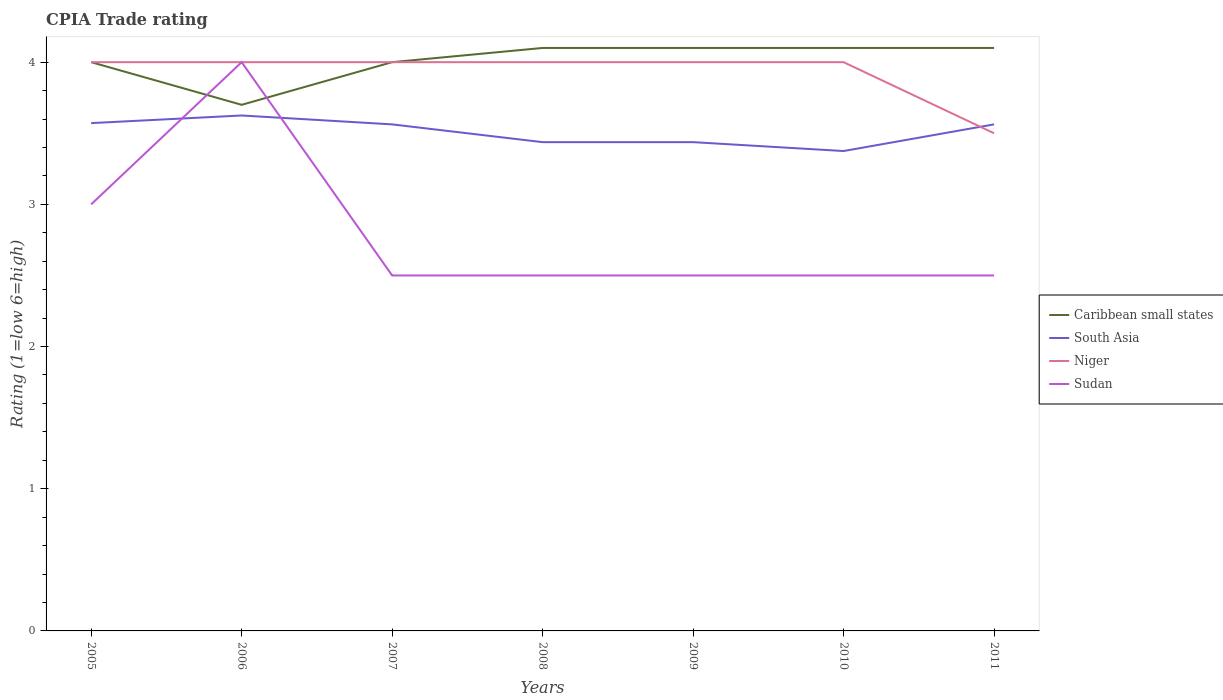Does the line corresponding to Niger intersect with the line corresponding to Sudan?
Your response must be concise. Yes. Is the number of lines equal to the number of legend labels?
Offer a terse response. Yes. Across all years, what is the maximum CPIA rating in Caribbean small states?
Offer a very short reply. 3.7. What is the total CPIA rating in Niger in the graph?
Keep it short and to the point. 0. What is the difference between the highest and the second highest CPIA rating in Caribbean small states?
Provide a short and direct response. 0.4. What is the difference between the highest and the lowest CPIA rating in South Asia?
Your answer should be very brief. 4. Is the CPIA rating in South Asia strictly greater than the CPIA rating in Niger over the years?
Make the answer very short. No. How many years are there in the graph?
Your answer should be very brief. 7. What is the difference between two consecutive major ticks on the Y-axis?
Keep it short and to the point. 1. Are the values on the major ticks of Y-axis written in scientific E-notation?
Keep it short and to the point. No. How many legend labels are there?
Your answer should be compact. 4. How are the legend labels stacked?
Offer a terse response. Vertical. What is the title of the graph?
Ensure brevity in your answer.  CPIA Trade rating. Does "Cote d'Ivoire" appear as one of the legend labels in the graph?
Your response must be concise. No. What is the label or title of the X-axis?
Keep it short and to the point. Years. What is the label or title of the Y-axis?
Your answer should be very brief. Rating (1=low 6=high). What is the Rating (1=low 6=high) of South Asia in 2005?
Provide a succinct answer. 3.57. What is the Rating (1=low 6=high) in South Asia in 2006?
Your answer should be very brief. 3.62. What is the Rating (1=low 6=high) in Caribbean small states in 2007?
Make the answer very short. 4. What is the Rating (1=low 6=high) in South Asia in 2007?
Keep it short and to the point. 3.56. What is the Rating (1=low 6=high) of Niger in 2007?
Offer a terse response. 4. What is the Rating (1=low 6=high) in Sudan in 2007?
Keep it short and to the point. 2.5. What is the Rating (1=low 6=high) in South Asia in 2008?
Your answer should be very brief. 3.44. What is the Rating (1=low 6=high) in Caribbean small states in 2009?
Your answer should be very brief. 4.1. What is the Rating (1=low 6=high) of South Asia in 2009?
Provide a succinct answer. 3.44. What is the Rating (1=low 6=high) in Niger in 2009?
Your answer should be compact. 4. What is the Rating (1=low 6=high) of Sudan in 2009?
Make the answer very short. 2.5. What is the Rating (1=low 6=high) in Caribbean small states in 2010?
Make the answer very short. 4.1. What is the Rating (1=low 6=high) in South Asia in 2010?
Offer a very short reply. 3.38. What is the Rating (1=low 6=high) of Niger in 2010?
Provide a short and direct response. 4. What is the Rating (1=low 6=high) in Sudan in 2010?
Your answer should be very brief. 2.5. What is the Rating (1=low 6=high) in South Asia in 2011?
Your answer should be very brief. 3.56. What is the Rating (1=low 6=high) of Niger in 2011?
Your response must be concise. 3.5. Across all years, what is the maximum Rating (1=low 6=high) in South Asia?
Provide a short and direct response. 3.62. Across all years, what is the maximum Rating (1=low 6=high) of Sudan?
Make the answer very short. 4. Across all years, what is the minimum Rating (1=low 6=high) in South Asia?
Ensure brevity in your answer.  3.38. Across all years, what is the minimum Rating (1=low 6=high) in Niger?
Ensure brevity in your answer.  3.5. What is the total Rating (1=low 6=high) of Caribbean small states in the graph?
Provide a succinct answer. 28.1. What is the total Rating (1=low 6=high) of South Asia in the graph?
Offer a very short reply. 24.57. What is the total Rating (1=low 6=high) of Niger in the graph?
Your response must be concise. 27.5. What is the total Rating (1=low 6=high) of Sudan in the graph?
Offer a terse response. 19.5. What is the difference between the Rating (1=low 6=high) in South Asia in 2005 and that in 2006?
Offer a terse response. -0.05. What is the difference between the Rating (1=low 6=high) of Sudan in 2005 and that in 2006?
Keep it short and to the point. -1. What is the difference between the Rating (1=low 6=high) in Caribbean small states in 2005 and that in 2007?
Offer a terse response. 0. What is the difference between the Rating (1=low 6=high) of South Asia in 2005 and that in 2007?
Your answer should be very brief. 0.01. What is the difference between the Rating (1=low 6=high) of Niger in 2005 and that in 2007?
Ensure brevity in your answer.  0. What is the difference between the Rating (1=low 6=high) of Caribbean small states in 2005 and that in 2008?
Your answer should be very brief. -0.1. What is the difference between the Rating (1=low 6=high) of South Asia in 2005 and that in 2008?
Give a very brief answer. 0.13. What is the difference between the Rating (1=low 6=high) in Sudan in 2005 and that in 2008?
Ensure brevity in your answer.  0.5. What is the difference between the Rating (1=low 6=high) of Caribbean small states in 2005 and that in 2009?
Provide a short and direct response. -0.1. What is the difference between the Rating (1=low 6=high) of South Asia in 2005 and that in 2009?
Ensure brevity in your answer.  0.13. What is the difference between the Rating (1=low 6=high) of Sudan in 2005 and that in 2009?
Offer a terse response. 0.5. What is the difference between the Rating (1=low 6=high) of Caribbean small states in 2005 and that in 2010?
Your response must be concise. -0.1. What is the difference between the Rating (1=low 6=high) in South Asia in 2005 and that in 2010?
Your answer should be very brief. 0.2. What is the difference between the Rating (1=low 6=high) in Niger in 2005 and that in 2010?
Offer a terse response. 0. What is the difference between the Rating (1=low 6=high) in South Asia in 2005 and that in 2011?
Your response must be concise. 0.01. What is the difference between the Rating (1=low 6=high) in Niger in 2005 and that in 2011?
Your answer should be compact. 0.5. What is the difference between the Rating (1=low 6=high) of Caribbean small states in 2006 and that in 2007?
Offer a very short reply. -0.3. What is the difference between the Rating (1=low 6=high) in South Asia in 2006 and that in 2007?
Your response must be concise. 0.06. What is the difference between the Rating (1=low 6=high) in Sudan in 2006 and that in 2007?
Provide a succinct answer. 1.5. What is the difference between the Rating (1=low 6=high) of South Asia in 2006 and that in 2008?
Your answer should be compact. 0.19. What is the difference between the Rating (1=low 6=high) in South Asia in 2006 and that in 2009?
Your response must be concise. 0.19. What is the difference between the Rating (1=low 6=high) of Niger in 2006 and that in 2009?
Provide a short and direct response. 0. What is the difference between the Rating (1=low 6=high) of Caribbean small states in 2006 and that in 2010?
Your answer should be very brief. -0.4. What is the difference between the Rating (1=low 6=high) in South Asia in 2006 and that in 2010?
Provide a short and direct response. 0.25. What is the difference between the Rating (1=low 6=high) of Sudan in 2006 and that in 2010?
Provide a short and direct response. 1.5. What is the difference between the Rating (1=low 6=high) in Caribbean small states in 2006 and that in 2011?
Your answer should be compact. -0.4. What is the difference between the Rating (1=low 6=high) in South Asia in 2006 and that in 2011?
Provide a short and direct response. 0.06. What is the difference between the Rating (1=low 6=high) of Niger in 2006 and that in 2011?
Keep it short and to the point. 0.5. What is the difference between the Rating (1=low 6=high) in Sudan in 2006 and that in 2011?
Offer a terse response. 1.5. What is the difference between the Rating (1=low 6=high) in Caribbean small states in 2007 and that in 2009?
Your response must be concise. -0.1. What is the difference between the Rating (1=low 6=high) of Niger in 2007 and that in 2009?
Offer a very short reply. 0. What is the difference between the Rating (1=low 6=high) of Caribbean small states in 2007 and that in 2010?
Offer a terse response. -0.1. What is the difference between the Rating (1=low 6=high) in South Asia in 2007 and that in 2010?
Your answer should be compact. 0.19. What is the difference between the Rating (1=low 6=high) in Sudan in 2007 and that in 2010?
Offer a very short reply. 0. What is the difference between the Rating (1=low 6=high) of Caribbean small states in 2007 and that in 2011?
Offer a very short reply. -0.1. What is the difference between the Rating (1=low 6=high) of South Asia in 2007 and that in 2011?
Ensure brevity in your answer.  0. What is the difference between the Rating (1=low 6=high) of Niger in 2007 and that in 2011?
Ensure brevity in your answer.  0.5. What is the difference between the Rating (1=low 6=high) of Sudan in 2007 and that in 2011?
Make the answer very short. 0. What is the difference between the Rating (1=low 6=high) in Niger in 2008 and that in 2009?
Make the answer very short. 0. What is the difference between the Rating (1=low 6=high) in South Asia in 2008 and that in 2010?
Give a very brief answer. 0.06. What is the difference between the Rating (1=low 6=high) in South Asia in 2008 and that in 2011?
Make the answer very short. -0.12. What is the difference between the Rating (1=low 6=high) of Caribbean small states in 2009 and that in 2010?
Offer a terse response. 0. What is the difference between the Rating (1=low 6=high) in South Asia in 2009 and that in 2010?
Provide a succinct answer. 0.06. What is the difference between the Rating (1=low 6=high) in Niger in 2009 and that in 2010?
Keep it short and to the point. 0. What is the difference between the Rating (1=low 6=high) in South Asia in 2009 and that in 2011?
Keep it short and to the point. -0.12. What is the difference between the Rating (1=low 6=high) of Sudan in 2009 and that in 2011?
Provide a succinct answer. 0. What is the difference between the Rating (1=low 6=high) in South Asia in 2010 and that in 2011?
Offer a terse response. -0.19. What is the difference between the Rating (1=low 6=high) of Niger in 2010 and that in 2011?
Your response must be concise. 0.5. What is the difference between the Rating (1=low 6=high) of Sudan in 2010 and that in 2011?
Provide a short and direct response. 0. What is the difference between the Rating (1=low 6=high) in Caribbean small states in 2005 and the Rating (1=low 6=high) in South Asia in 2006?
Your answer should be very brief. 0.38. What is the difference between the Rating (1=low 6=high) in Caribbean small states in 2005 and the Rating (1=low 6=high) in Niger in 2006?
Provide a short and direct response. 0. What is the difference between the Rating (1=low 6=high) in Caribbean small states in 2005 and the Rating (1=low 6=high) in Sudan in 2006?
Provide a succinct answer. 0. What is the difference between the Rating (1=low 6=high) in South Asia in 2005 and the Rating (1=low 6=high) in Niger in 2006?
Your response must be concise. -0.43. What is the difference between the Rating (1=low 6=high) in South Asia in 2005 and the Rating (1=low 6=high) in Sudan in 2006?
Your answer should be very brief. -0.43. What is the difference between the Rating (1=low 6=high) of Caribbean small states in 2005 and the Rating (1=low 6=high) of South Asia in 2007?
Ensure brevity in your answer.  0.44. What is the difference between the Rating (1=low 6=high) in Caribbean small states in 2005 and the Rating (1=low 6=high) in Niger in 2007?
Keep it short and to the point. 0. What is the difference between the Rating (1=low 6=high) in South Asia in 2005 and the Rating (1=low 6=high) in Niger in 2007?
Ensure brevity in your answer.  -0.43. What is the difference between the Rating (1=low 6=high) of South Asia in 2005 and the Rating (1=low 6=high) of Sudan in 2007?
Offer a very short reply. 1.07. What is the difference between the Rating (1=low 6=high) in Caribbean small states in 2005 and the Rating (1=low 6=high) in South Asia in 2008?
Your response must be concise. 0.56. What is the difference between the Rating (1=low 6=high) of Caribbean small states in 2005 and the Rating (1=low 6=high) of Niger in 2008?
Offer a terse response. 0. What is the difference between the Rating (1=low 6=high) of South Asia in 2005 and the Rating (1=low 6=high) of Niger in 2008?
Your answer should be very brief. -0.43. What is the difference between the Rating (1=low 6=high) of South Asia in 2005 and the Rating (1=low 6=high) of Sudan in 2008?
Your answer should be compact. 1.07. What is the difference between the Rating (1=low 6=high) in Niger in 2005 and the Rating (1=low 6=high) in Sudan in 2008?
Your response must be concise. 1.5. What is the difference between the Rating (1=low 6=high) in Caribbean small states in 2005 and the Rating (1=low 6=high) in South Asia in 2009?
Ensure brevity in your answer.  0.56. What is the difference between the Rating (1=low 6=high) in Caribbean small states in 2005 and the Rating (1=low 6=high) in Sudan in 2009?
Offer a very short reply. 1.5. What is the difference between the Rating (1=low 6=high) in South Asia in 2005 and the Rating (1=low 6=high) in Niger in 2009?
Your answer should be compact. -0.43. What is the difference between the Rating (1=low 6=high) in South Asia in 2005 and the Rating (1=low 6=high) in Sudan in 2009?
Keep it short and to the point. 1.07. What is the difference between the Rating (1=low 6=high) of Caribbean small states in 2005 and the Rating (1=low 6=high) of South Asia in 2010?
Offer a very short reply. 0.62. What is the difference between the Rating (1=low 6=high) in South Asia in 2005 and the Rating (1=low 6=high) in Niger in 2010?
Your response must be concise. -0.43. What is the difference between the Rating (1=low 6=high) of South Asia in 2005 and the Rating (1=low 6=high) of Sudan in 2010?
Your answer should be very brief. 1.07. What is the difference between the Rating (1=low 6=high) in Caribbean small states in 2005 and the Rating (1=low 6=high) in South Asia in 2011?
Provide a short and direct response. 0.44. What is the difference between the Rating (1=low 6=high) in Caribbean small states in 2005 and the Rating (1=low 6=high) in Niger in 2011?
Offer a very short reply. 0.5. What is the difference between the Rating (1=low 6=high) of Caribbean small states in 2005 and the Rating (1=low 6=high) of Sudan in 2011?
Offer a very short reply. 1.5. What is the difference between the Rating (1=low 6=high) in South Asia in 2005 and the Rating (1=low 6=high) in Niger in 2011?
Your answer should be compact. 0.07. What is the difference between the Rating (1=low 6=high) of South Asia in 2005 and the Rating (1=low 6=high) of Sudan in 2011?
Your response must be concise. 1.07. What is the difference between the Rating (1=low 6=high) in Niger in 2005 and the Rating (1=low 6=high) in Sudan in 2011?
Your response must be concise. 1.5. What is the difference between the Rating (1=low 6=high) of Caribbean small states in 2006 and the Rating (1=low 6=high) of South Asia in 2007?
Give a very brief answer. 0.14. What is the difference between the Rating (1=low 6=high) in Caribbean small states in 2006 and the Rating (1=low 6=high) in Sudan in 2007?
Your answer should be very brief. 1.2. What is the difference between the Rating (1=low 6=high) in South Asia in 2006 and the Rating (1=low 6=high) in Niger in 2007?
Keep it short and to the point. -0.38. What is the difference between the Rating (1=low 6=high) in South Asia in 2006 and the Rating (1=low 6=high) in Sudan in 2007?
Your answer should be very brief. 1.12. What is the difference between the Rating (1=low 6=high) in Niger in 2006 and the Rating (1=low 6=high) in Sudan in 2007?
Your answer should be compact. 1.5. What is the difference between the Rating (1=low 6=high) in Caribbean small states in 2006 and the Rating (1=low 6=high) in South Asia in 2008?
Make the answer very short. 0.26. What is the difference between the Rating (1=low 6=high) in Caribbean small states in 2006 and the Rating (1=low 6=high) in Niger in 2008?
Give a very brief answer. -0.3. What is the difference between the Rating (1=low 6=high) of Caribbean small states in 2006 and the Rating (1=low 6=high) of Sudan in 2008?
Make the answer very short. 1.2. What is the difference between the Rating (1=low 6=high) in South Asia in 2006 and the Rating (1=low 6=high) in Niger in 2008?
Your answer should be very brief. -0.38. What is the difference between the Rating (1=low 6=high) of Caribbean small states in 2006 and the Rating (1=low 6=high) of South Asia in 2009?
Provide a succinct answer. 0.26. What is the difference between the Rating (1=low 6=high) of Caribbean small states in 2006 and the Rating (1=low 6=high) of Niger in 2009?
Provide a short and direct response. -0.3. What is the difference between the Rating (1=low 6=high) in South Asia in 2006 and the Rating (1=low 6=high) in Niger in 2009?
Keep it short and to the point. -0.38. What is the difference between the Rating (1=low 6=high) in South Asia in 2006 and the Rating (1=low 6=high) in Sudan in 2009?
Your response must be concise. 1.12. What is the difference between the Rating (1=low 6=high) in Caribbean small states in 2006 and the Rating (1=low 6=high) in South Asia in 2010?
Your answer should be compact. 0.33. What is the difference between the Rating (1=low 6=high) in Caribbean small states in 2006 and the Rating (1=low 6=high) in Niger in 2010?
Give a very brief answer. -0.3. What is the difference between the Rating (1=low 6=high) of South Asia in 2006 and the Rating (1=low 6=high) of Niger in 2010?
Offer a terse response. -0.38. What is the difference between the Rating (1=low 6=high) in South Asia in 2006 and the Rating (1=low 6=high) in Sudan in 2010?
Your answer should be compact. 1.12. What is the difference between the Rating (1=low 6=high) in Caribbean small states in 2006 and the Rating (1=low 6=high) in South Asia in 2011?
Give a very brief answer. 0.14. What is the difference between the Rating (1=low 6=high) of Caribbean small states in 2006 and the Rating (1=low 6=high) of Niger in 2011?
Offer a terse response. 0.2. What is the difference between the Rating (1=low 6=high) of Caribbean small states in 2006 and the Rating (1=low 6=high) of Sudan in 2011?
Offer a very short reply. 1.2. What is the difference between the Rating (1=low 6=high) of South Asia in 2006 and the Rating (1=low 6=high) of Niger in 2011?
Keep it short and to the point. 0.12. What is the difference between the Rating (1=low 6=high) of South Asia in 2006 and the Rating (1=low 6=high) of Sudan in 2011?
Provide a short and direct response. 1.12. What is the difference between the Rating (1=low 6=high) in Caribbean small states in 2007 and the Rating (1=low 6=high) in South Asia in 2008?
Provide a succinct answer. 0.56. What is the difference between the Rating (1=low 6=high) in Caribbean small states in 2007 and the Rating (1=low 6=high) in Sudan in 2008?
Make the answer very short. 1.5. What is the difference between the Rating (1=low 6=high) of South Asia in 2007 and the Rating (1=low 6=high) of Niger in 2008?
Ensure brevity in your answer.  -0.44. What is the difference between the Rating (1=low 6=high) in Caribbean small states in 2007 and the Rating (1=low 6=high) in South Asia in 2009?
Offer a terse response. 0.56. What is the difference between the Rating (1=low 6=high) in Caribbean small states in 2007 and the Rating (1=low 6=high) in Sudan in 2009?
Ensure brevity in your answer.  1.5. What is the difference between the Rating (1=low 6=high) in South Asia in 2007 and the Rating (1=low 6=high) in Niger in 2009?
Ensure brevity in your answer.  -0.44. What is the difference between the Rating (1=low 6=high) of Niger in 2007 and the Rating (1=low 6=high) of Sudan in 2009?
Provide a short and direct response. 1.5. What is the difference between the Rating (1=low 6=high) of Caribbean small states in 2007 and the Rating (1=low 6=high) of South Asia in 2010?
Provide a short and direct response. 0.62. What is the difference between the Rating (1=low 6=high) of Caribbean small states in 2007 and the Rating (1=low 6=high) of Sudan in 2010?
Your response must be concise. 1.5. What is the difference between the Rating (1=low 6=high) in South Asia in 2007 and the Rating (1=low 6=high) in Niger in 2010?
Offer a terse response. -0.44. What is the difference between the Rating (1=low 6=high) of Niger in 2007 and the Rating (1=low 6=high) of Sudan in 2010?
Offer a terse response. 1.5. What is the difference between the Rating (1=low 6=high) in Caribbean small states in 2007 and the Rating (1=low 6=high) in South Asia in 2011?
Provide a short and direct response. 0.44. What is the difference between the Rating (1=low 6=high) in Caribbean small states in 2007 and the Rating (1=low 6=high) in Niger in 2011?
Ensure brevity in your answer.  0.5. What is the difference between the Rating (1=low 6=high) in Caribbean small states in 2007 and the Rating (1=low 6=high) in Sudan in 2011?
Make the answer very short. 1.5. What is the difference between the Rating (1=low 6=high) of South Asia in 2007 and the Rating (1=low 6=high) of Niger in 2011?
Your answer should be compact. 0.06. What is the difference between the Rating (1=low 6=high) in South Asia in 2007 and the Rating (1=low 6=high) in Sudan in 2011?
Your answer should be very brief. 1.06. What is the difference between the Rating (1=low 6=high) in Niger in 2007 and the Rating (1=low 6=high) in Sudan in 2011?
Provide a succinct answer. 1.5. What is the difference between the Rating (1=low 6=high) in Caribbean small states in 2008 and the Rating (1=low 6=high) in South Asia in 2009?
Provide a succinct answer. 0.66. What is the difference between the Rating (1=low 6=high) of South Asia in 2008 and the Rating (1=low 6=high) of Niger in 2009?
Your answer should be very brief. -0.56. What is the difference between the Rating (1=low 6=high) of Caribbean small states in 2008 and the Rating (1=low 6=high) of South Asia in 2010?
Your response must be concise. 0.72. What is the difference between the Rating (1=low 6=high) in Caribbean small states in 2008 and the Rating (1=low 6=high) in Sudan in 2010?
Provide a short and direct response. 1.6. What is the difference between the Rating (1=low 6=high) of South Asia in 2008 and the Rating (1=low 6=high) of Niger in 2010?
Provide a succinct answer. -0.56. What is the difference between the Rating (1=low 6=high) in South Asia in 2008 and the Rating (1=low 6=high) in Sudan in 2010?
Provide a short and direct response. 0.94. What is the difference between the Rating (1=low 6=high) of Caribbean small states in 2008 and the Rating (1=low 6=high) of South Asia in 2011?
Ensure brevity in your answer.  0.54. What is the difference between the Rating (1=low 6=high) of Caribbean small states in 2008 and the Rating (1=low 6=high) of Niger in 2011?
Offer a terse response. 0.6. What is the difference between the Rating (1=low 6=high) in South Asia in 2008 and the Rating (1=low 6=high) in Niger in 2011?
Make the answer very short. -0.06. What is the difference between the Rating (1=low 6=high) of Niger in 2008 and the Rating (1=low 6=high) of Sudan in 2011?
Ensure brevity in your answer.  1.5. What is the difference between the Rating (1=low 6=high) of Caribbean small states in 2009 and the Rating (1=low 6=high) of South Asia in 2010?
Your answer should be compact. 0.72. What is the difference between the Rating (1=low 6=high) in Caribbean small states in 2009 and the Rating (1=low 6=high) in Niger in 2010?
Give a very brief answer. 0.1. What is the difference between the Rating (1=low 6=high) in South Asia in 2009 and the Rating (1=low 6=high) in Niger in 2010?
Make the answer very short. -0.56. What is the difference between the Rating (1=low 6=high) of South Asia in 2009 and the Rating (1=low 6=high) of Sudan in 2010?
Offer a very short reply. 0.94. What is the difference between the Rating (1=low 6=high) in Caribbean small states in 2009 and the Rating (1=low 6=high) in South Asia in 2011?
Ensure brevity in your answer.  0.54. What is the difference between the Rating (1=low 6=high) of Caribbean small states in 2009 and the Rating (1=low 6=high) of Niger in 2011?
Your answer should be compact. 0.6. What is the difference between the Rating (1=low 6=high) of South Asia in 2009 and the Rating (1=low 6=high) of Niger in 2011?
Ensure brevity in your answer.  -0.06. What is the difference between the Rating (1=low 6=high) in South Asia in 2009 and the Rating (1=low 6=high) in Sudan in 2011?
Your response must be concise. 0.94. What is the difference between the Rating (1=low 6=high) of Caribbean small states in 2010 and the Rating (1=low 6=high) of South Asia in 2011?
Provide a succinct answer. 0.54. What is the difference between the Rating (1=low 6=high) of Caribbean small states in 2010 and the Rating (1=low 6=high) of Niger in 2011?
Provide a succinct answer. 0.6. What is the difference between the Rating (1=low 6=high) of Caribbean small states in 2010 and the Rating (1=low 6=high) of Sudan in 2011?
Ensure brevity in your answer.  1.6. What is the difference between the Rating (1=low 6=high) in South Asia in 2010 and the Rating (1=low 6=high) in Niger in 2011?
Provide a short and direct response. -0.12. What is the difference between the Rating (1=low 6=high) of South Asia in 2010 and the Rating (1=low 6=high) of Sudan in 2011?
Provide a succinct answer. 0.88. What is the difference between the Rating (1=low 6=high) in Niger in 2010 and the Rating (1=low 6=high) in Sudan in 2011?
Keep it short and to the point. 1.5. What is the average Rating (1=low 6=high) of Caribbean small states per year?
Ensure brevity in your answer.  4.01. What is the average Rating (1=low 6=high) of South Asia per year?
Your answer should be compact. 3.51. What is the average Rating (1=low 6=high) of Niger per year?
Give a very brief answer. 3.93. What is the average Rating (1=low 6=high) of Sudan per year?
Ensure brevity in your answer.  2.79. In the year 2005, what is the difference between the Rating (1=low 6=high) of Caribbean small states and Rating (1=low 6=high) of South Asia?
Ensure brevity in your answer.  0.43. In the year 2005, what is the difference between the Rating (1=low 6=high) of South Asia and Rating (1=low 6=high) of Niger?
Provide a succinct answer. -0.43. In the year 2005, what is the difference between the Rating (1=low 6=high) in Niger and Rating (1=low 6=high) in Sudan?
Ensure brevity in your answer.  1. In the year 2006, what is the difference between the Rating (1=low 6=high) of Caribbean small states and Rating (1=low 6=high) of South Asia?
Your answer should be very brief. 0.07. In the year 2006, what is the difference between the Rating (1=low 6=high) in South Asia and Rating (1=low 6=high) in Niger?
Offer a very short reply. -0.38. In the year 2006, what is the difference between the Rating (1=low 6=high) of South Asia and Rating (1=low 6=high) of Sudan?
Provide a succinct answer. -0.38. In the year 2006, what is the difference between the Rating (1=low 6=high) in Niger and Rating (1=low 6=high) in Sudan?
Your answer should be very brief. 0. In the year 2007, what is the difference between the Rating (1=low 6=high) in Caribbean small states and Rating (1=low 6=high) in South Asia?
Your answer should be compact. 0.44. In the year 2007, what is the difference between the Rating (1=low 6=high) of Caribbean small states and Rating (1=low 6=high) of Sudan?
Your response must be concise. 1.5. In the year 2007, what is the difference between the Rating (1=low 6=high) in South Asia and Rating (1=low 6=high) in Niger?
Your answer should be compact. -0.44. In the year 2007, what is the difference between the Rating (1=low 6=high) in South Asia and Rating (1=low 6=high) in Sudan?
Keep it short and to the point. 1.06. In the year 2008, what is the difference between the Rating (1=low 6=high) of Caribbean small states and Rating (1=low 6=high) of South Asia?
Your answer should be very brief. 0.66. In the year 2008, what is the difference between the Rating (1=low 6=high) in South Asia and Rating (1=low 6=high) in Niger?
Give a very brief answer. -0.56. In the year 2008, what is the difference between the Rating (1=low 6=high) in South Asia and Rating (1=low 6=high) in Sudan?
Your response must be concise. 0.94. In the year 2008, what is the difference between the Rating (1=low 6=high) of Niger and Rating (1=low 6=high) of Sudan?
Keep it short and to the point. 1.5. In the year 2009, what is the difference between the Rating (1=low 6=high) in Caribbean small states and Rating (1=low 6=high) in South Asia?
Provide a short and direct response. 0.66. In the year 2009, what is the difference between the Rating (1=low 6=high) in South Asia and Rating (1=low 6=high) in Niger?
Give a very brief answer. -0.56. In the year 2009, what is the difference between the Rating (1=low 6=high) of South Asia and Rating (1=low 6=high) of Sudan?
Offer a terse response. 0.94. In the year 2009, what is the difference between the Rating (1=low 6=high) of Niger and Rating (1=low 6=high) of Sudan?
Give a very brief answer. 1.5. In the year 2010, what is the difference between the Rating (1=low 6=high) of Caribbean small states and Rating (1=low 6=high) of South Asia?
Ensure brevity in your answer.  0.72. In the year 2010, what is the difference between the Rating (1=low 6=high) of Caribbean small states and Rating (1=low 6=high) of Niger?
Offer a terse response. 0.1. In the year 2010, what is the difference between the Rating (1=low 6=high) in Caribbean small states and Rating (1=low 6=high) in Sudan?
Your answer should be very brief. 1.6. In the year 2010, what is the difference between the Rating (1=low 6=high) of South Asia and Rating (1=low 6=high) of Niger?
Give a very brief answer. -0.62. In the year 2010, what is the difference between the Rating (1=low 6=high) in Niger and Rating (1=low 6=high) in Sudan?
Your answer should be compact. 1.5. In the year 2011, what is the difference between the Rating (1=low 6=high) of Caribbean small states and Rating (1=low 6=high) of South Asia?
Ensure brevity in your answer.  0.54. In the year 2011, what is the difference between the Rating (1=low 6=high) of South Asia and Rating (1=low 6=high) of Niger?
Make the answer very short. 0.06. In the year 2011, what is the difference between the Rating (1=low 6=high) of South Asia and Rating (1=low 6=high) of Sudan?
Give a very brief answer. 1.06. What is the ratio of the Rating (1=low 6=high) of Caribbean small states in 2005 to that in 2006?
Provide a succinct answer. 1.08. What is the ratio of the Rating (1=low 6=high) of South Asia in 2005 to that in 2006?
Offer a terse response. 0.99. What is the ratio of the Rating (1=low 6=high) of South Asia in 2005 to that in 2007?
Offer a very short reply. 1. What is the ratio of the Rating (1=low 6=high) of Sudan in 2005 to that in 2007?
Offer a terse response. 1.2. What is the ratio of the Rating (1=low 6=high) of Caribbean small states in 2005 to that in 2008?
Your answer should be compact. 0.98. What is the ratio of the Rating (1=low 6=high) in South Asia in 2005 to that in 2008?
Offer a terse response. 1.04. What is the ratio of the Rating (1=low 6=high) of Caribbean small states in 2005 to that in 2009?
Give a very brief answer. 0.98. What is the ratio of the Rating (1=low 6=high) in South Asia in 2005 to that in 2009?
Your response must be concise. 1.04. What is the ratio of the Rating (1=low 6=high) of Caribbean small states in 2005 to that in 2010?
Offer a terse response. 0.98. What is the ratio of the Rating (1=low 6=high) in South Asia in 2005 to that in 2010?
Provide a succinct answer. 1.06. What is the ratio of the Rating (1=low 6=high) in Sudan in 2005 to that in 2010?
Your answer should be compact. 1.2. What is the ratio of the Rating (1=low 6=high) in Caribbean small states in 2005 to that in 2011?
Your answer should be compact. 0.98. What is the ratio of the Rating (1=low 6=high) of Niger in 2005 to that in 2011?
Your answer should be very brief. 1.14. What is the ratio of the Rating (1=low 6=high) in Sudan in 2005 to that in 2011?
Your response must be concise. 1.2. What is the ratio of the Rating (1=low 6=high) of Caribbean small states in 2006 to that in 2007?
Make the answer very short. 0.93. What is the ratio of the Rating (1=low 6=high) in South Asia in 2006 to that in 2007?
Your answer should be compact. 1.02. What is the ratio of the Rating (1=low 6=high) of Niger in 2006 to that in 2007?
Ensure brevity in your answer.  1. What is the ratio of the Rating (1=low 6=high) in Sudan in 2006 to that in 2007?
Offer a very short reply. 1.6. What is the ratio of the Rating (1=low 6=high) in Caribbean small states in 2006 to that in 2008?
Offer a terse response. 0.9. What is the ratio of the Rating (1=low 6=high) in South Asia in 2006 to that in 2008?
Keep it short and to the point. 1.05. What is the ratio of the Rating (1=low 6=high) of Niger in 2006 to that in 2008?
Make the answer very short. 1. What is the ratio of the Rating (1=low 6=high) of Caribbean small states in 2006 to that in 2009?
Your answer should be very brief. 0.9. What is the ratio of the Rating (1=low 6=high) in South Asia in 2006 to that in 2009?
Your answer should be very brief. 1.05. What is the ratio of the Rating (1=low 6=high) of Niger in 2006 to that in 2009?
Provide a short and direct response. 1. What is the ratio of the Rating (1=low 6=high) in Sudan in 2006 to that in 2009?
Your answer should be compact. 1.6. What is the ratio of the Rating (1=low 6=high) of Caribbean small states in 2006 to that in 2010?
Your response must be concise. 0.9. What is the ratio of the Rating (1=low 6=high) of South Asia in 2006 to that in 2010?
Provide a succinct answer. 1.07. What is the ratio of the Rating (1=low 6=high) of Caribbean small states in 2006 to that in 2011?
Your answer should be very brief. 0.9. What is the ratio of the Rating (1=low 6=high) of South Asia in 2006 to that in 2011?
Keep it short and to the point. 1.02. What is the ratio of the Rating (1=low 6=high) in Sudan in 2006 to that in 2011?
Provide a short and direct response. 1.6. What is the ratio of the Rating (1=low 6=high) in Caribbean small states in 2007 to that in 2008?
Your response must be concise. 0.98. What is the ratio of the Rating (1=low 6=high) in South Asia in 2007 to that in 2008?
Your answer should be compact. 1.04. What is the ratio of the Rating (1=low 6=high) of Niger in 2007 to that in 2008?
Your response must be concise. 1. What is the ratio of the Rating (1=low 6=high) of Caribbean small states in 2007 to that in 2009?
Offer a very short reply. 0.98. What is the ratio of the Rating (1=low 6=high) in South Asia in 2007 to that in 2009?
Provide a short and direct response. 1.04. What is the ratio of the Rating (1=low 6=high) of Niger in 2007 to that in 2009?
Give a very brief answer. 1. What is the ratio of the Rating (1=low 6=high) in Sudan in 2007 to that in 2009?
Provide a succinct answer. 1. What is the ratio of the Rating (1=low 6=high) in Caribbean small states in 2007 to that in 2010?
Give a very brief answer. 0.98. What is the ratio of the Rating (1=low 6=high) of South Asia in 2007 to that in 2010?
Provide a short and direct response. 1.06. What is the ratio of the Rating (1=low 6=high) in Caribbean small states in 2007 to that in 2011?
Keep it short and to the point. 0.98. What is the ratio of the Rating (1=low 6=high) in Niger in 2007 to that in 2011?
Your answer should be very brief. 1.14. What is the ratio of the Rating (1=low 6=high) of Caribbean small states in 2008 to that in 2009?
Your answer should be very brief. 1. What is the ratio of the Rating (1=low 6=high) of South Asia in 2008 to that in 2009?
Offer a very short reply. 1. What is the ratio of the Rating (1=low 6=high) of South Asia in 2008 to that in 2010?
Offer a very short reply. 1.02. What is the ratio of the Rating (1=low 6=high) in Niger in 2008 to that in 2010?
Ensure brevity in your answer.  1. What is the ratio of the Rating (1=low 6=high) of Sudan in 2008 to that in 2010?
Provide a succinct answer. 1. What is the ratio of the Rating (1=low 6=high) of South Asia in 2008 to that in 2011?
Your answer should be compact. 0.96. What is the ratio of the Rating (1=low 6=high) in Niger in 2008 to that in 2011?
Your answer should be compact. 1.14. What is the ratio of the Rating (1=low 6=high) of South Asia in 2009 to that in 2010?
Keep it short and to the point. 1.02. What is the ratio of the Rating (1=low 6=high) of Caribbean small states in 2009 to that in 2011?
Provide a short and direct response. 1. What is the ratio of the Rating (1=low 6=high) of South Asia in 2009 to that in 2011?
Provide a short and direct response. 0.96. What is the ratio of the Rating (1=low 6=high) of Niger in 2009 to that in 2011?
Give a very brief answer. 1.14. What is the ratio of the Rating (1=low 6=high) of Sudan in 2009 to that in 2011?
Make the answer very short. 1. What is the ratio of the Rating (1=low 6=high) of Niger in 2010 to that in 2011?
Ensure brevity in your answer.  1.14. What is the difference between the highest and the second highest Rating (1=low 6=high) of South Asia?
Your answer should be compact. 0.05. What is the difference between the highest and the second highest Rating (1=low 6=high) of Niger?
Offer a very short reply. 0. What is the difference between the highest and the lowest Rating (1=low 6=high) of Niger?
Your answer should be compact. 0.5. 